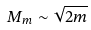Convert formula to latex. <formula><loc_0><loc_0><loc_500><loc_500>M _ { m } \sim \sqrt { 2 m }</formula> 